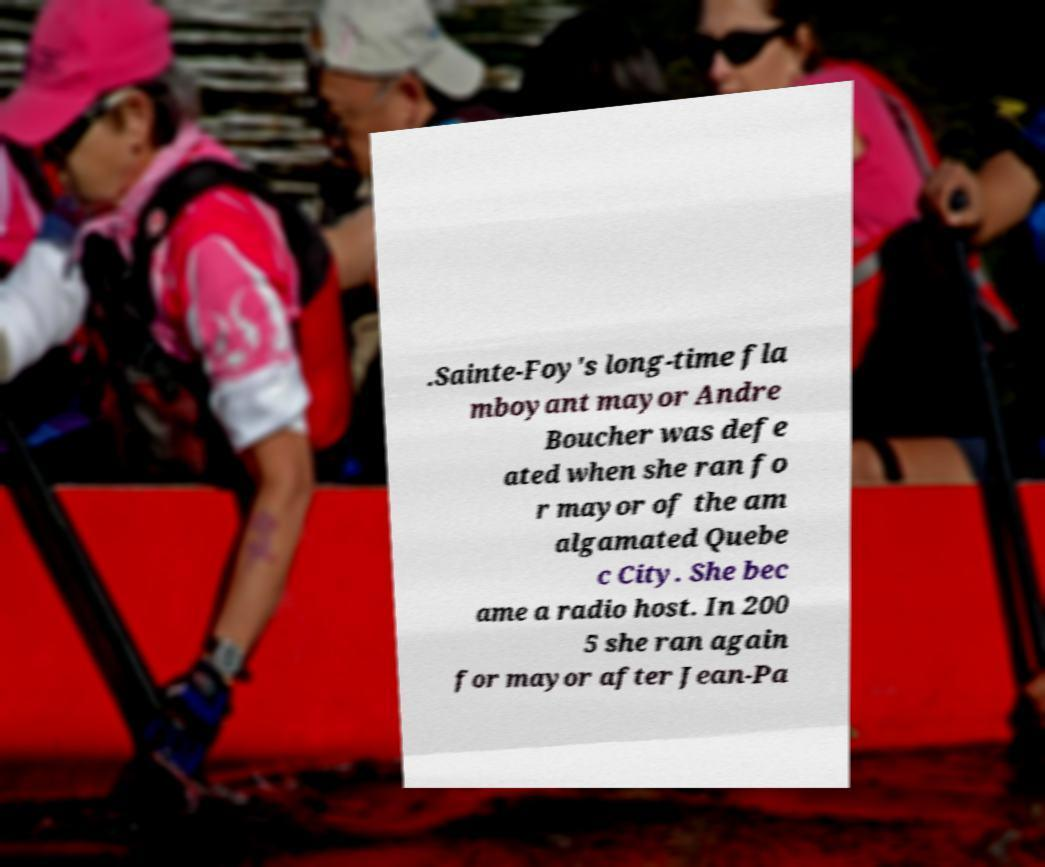There's text embedded in this image that I need extracted. Can you transcribe it verbatim? .Sainte-Foy's long-time fla mboyant mayor Andre Boucher was defe ated when she ran fo r mayor of the am algamated Quebe c City. She bec ame a radio host. In 200 5 she ran again for mayor after Jean-Pa 